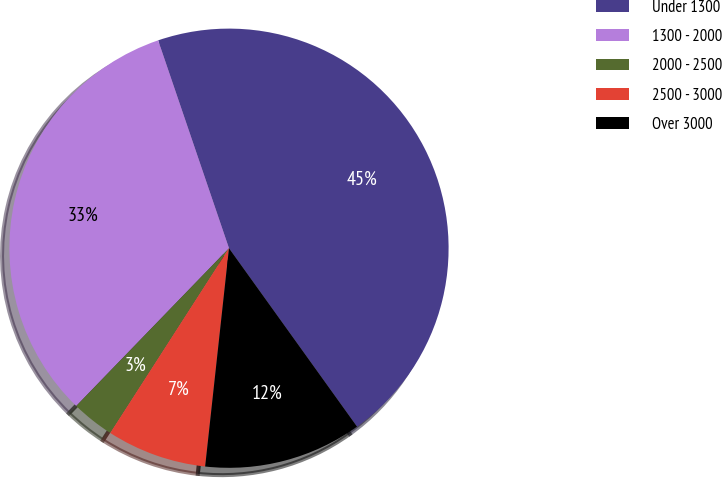Convert chart to OTSL. <chart><loc_0><loc_0><loc_500><loc_500><pie_chart><fcel>Under 1300<fcel>1300 - 2000<fcel>2000 - 2500<fcel>2500 - 3000<fcel>Over 3000<nl><fcel>45.32%<fcel>32.53%<fcel>3.15%<fcel>7.36%<fcel>11.64%<nl></chart> 